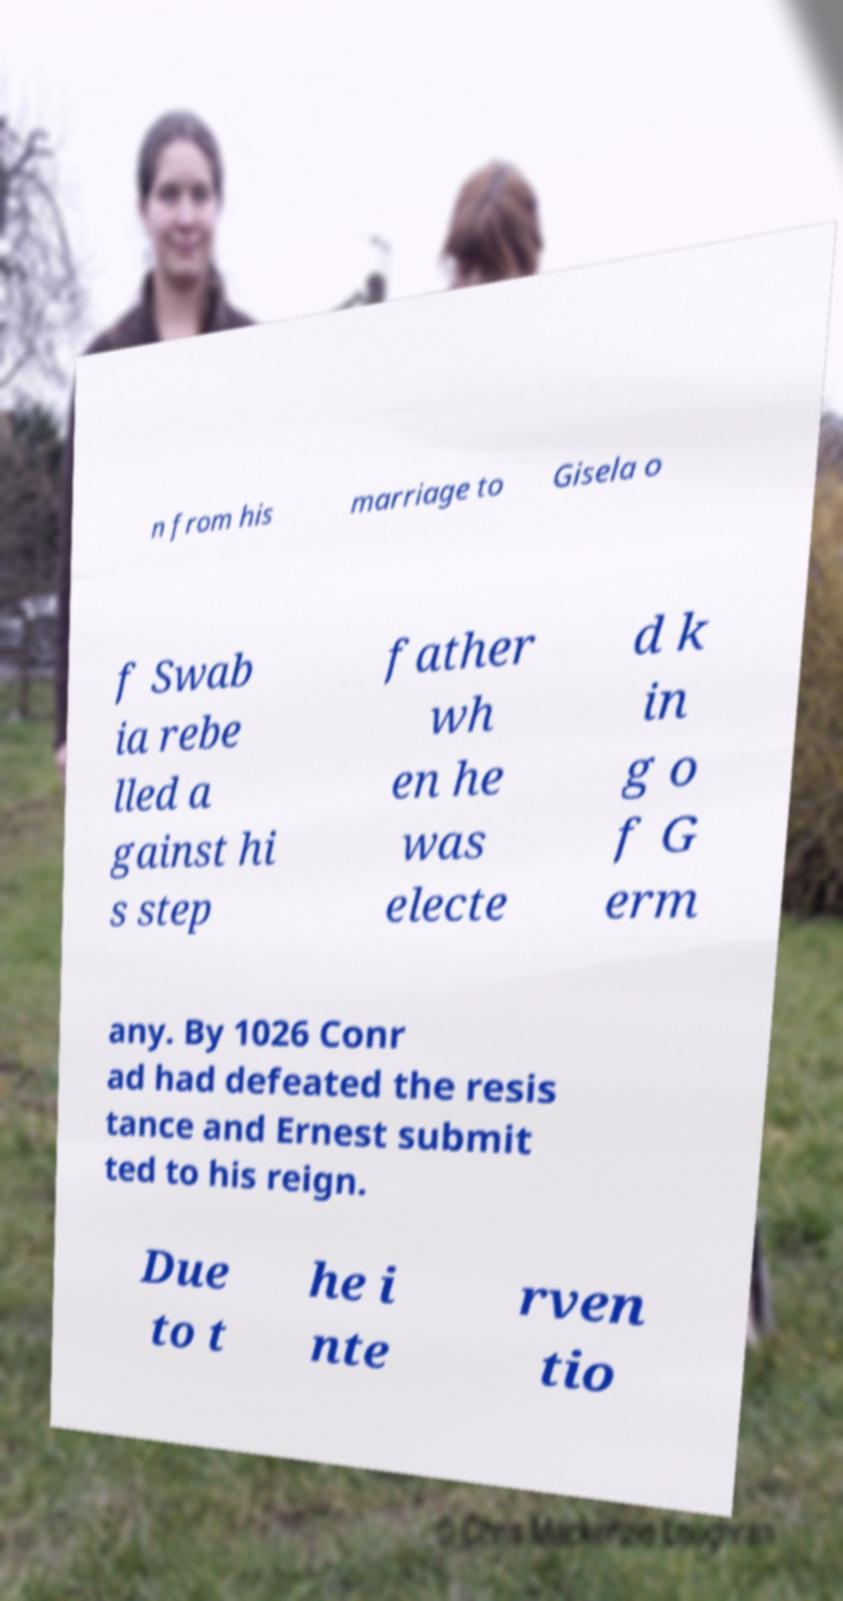Can you accurately transcribe the text from the provided image for me? n from his marriage to Gisela o f Swab ia rebe lled a gainst hi s step father wh en he was electe d k in g o f G erm any. By 1026 Conr ad had defeated the resis tance and Ernest submit ted to his reign. Due to t he i nte rven tio 